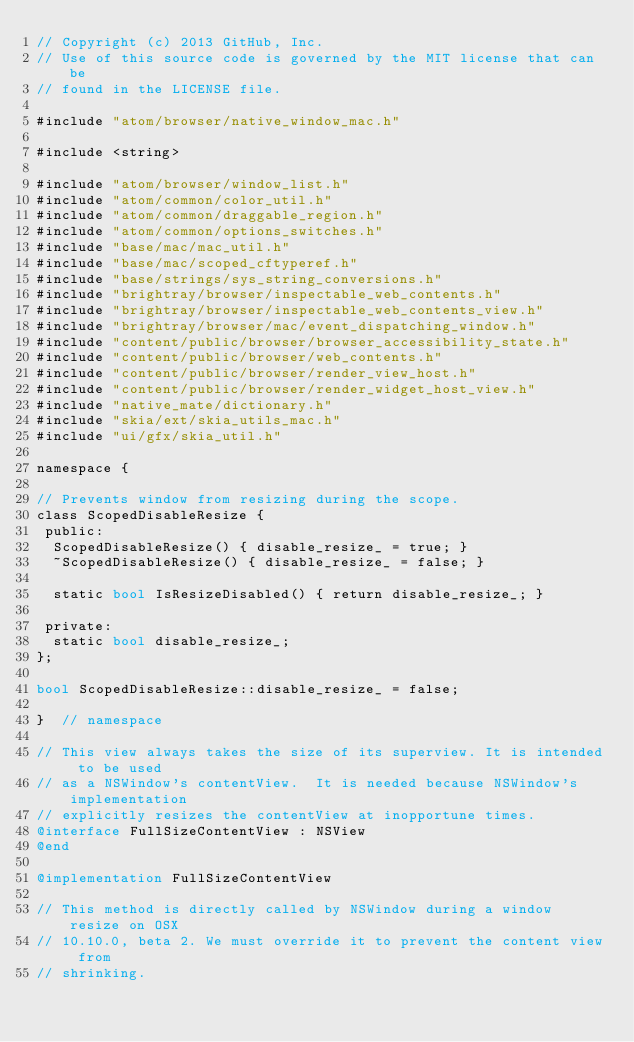<code> <loc_0><loc_0><loc_500><loc_500><_ObjectiveC_>// Copyright (c) 2013 GitHub, Inc.
// Use of this source code is governed by the MIT license that can be
// found in the LICENSE file.

#include "atom/browser/native_window_mac.h"

#include <string>

#include "atom/browser/window_list.h"
#include "atom/common/color_util.h"
#include "atom/common/draggable_region.h"
#include "atom/common/options_switches.h"
#include "base/mac/mac_util.h"
#include "base/mac/scoped_cftyperef.h"
#include "base/strings/sys_string_conversions.h"
#include "brightray/browser/inspectable_web_contents.h"
#include "brightray/browser/inspectable_web_contents_view.h"
#include "brightray/browser/mac/event_dispatching_window.h"
#include "content/public/browser/browser_accessibility_state.h"
#include "content/public/browser/web_contents.h"
#include "content/public/browser/render_view_host.h"
#include "content/public/browser/render_widget_host_view.h"
#include "native_mate/dictionary.h"
#include "skia/ext/skia_utils_mac.h"
#include "ui/gfx/skia_util.h"

namespace {

// Prevents window from resizing during the scope.
class ScopedDisableResize {
 public:
  ScopedDisableResize() { disable_resize_ = true; }
  ~ScopedDisableResize() { disable_resize_ = false; }

  static bool IsResizeDisabled() { return disable_resize_; }

 private:
  static bool disable_resize_;
};

bool ScopedDisableResize::disable_resize_ = false;

}  // namespace

// This view always takes the size of its superview. It is intended to be used
// as a NSWindow's contentView.  It is needed because NSWindow's implementation
// explicitly resizes the contentView at inopportune times.
@interface FullSizeContentView : NSView
@end

@implementation FullSizeContentView

// This method is directly called by NSWindow during a window resize on OSX
// 10.10.0, beta 2. We must override it to prevent the content view from
// shrinking.</code> 